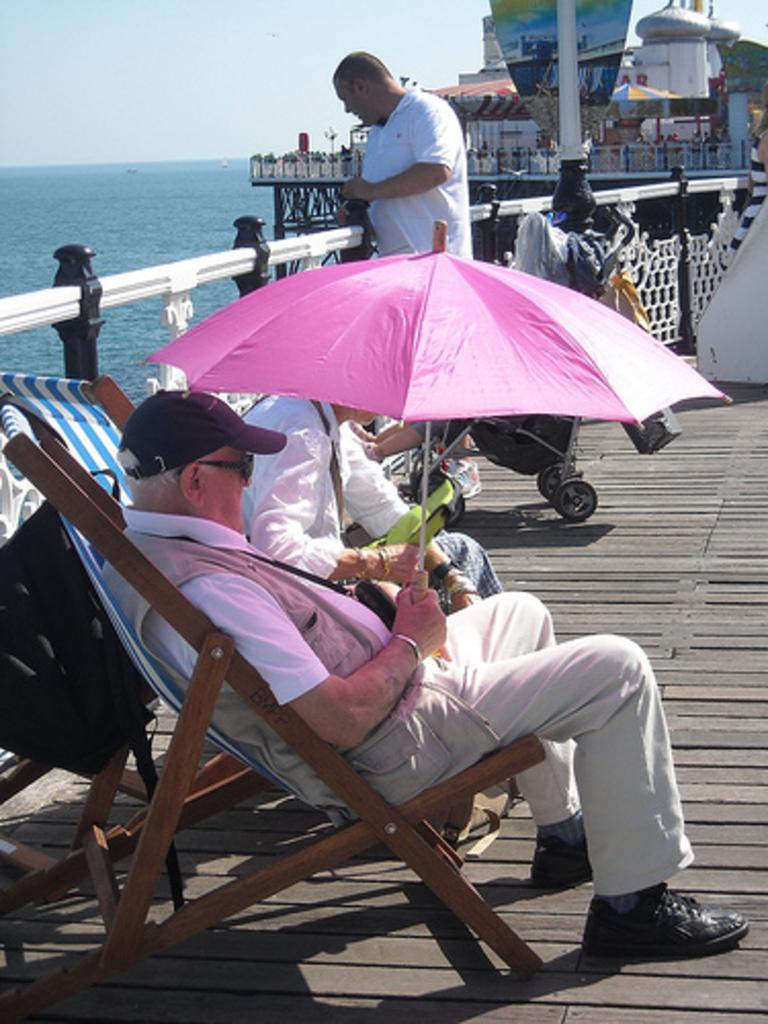Could you give a brief overview of what you see in this image? As we can see in the image there are few people here and there, chair, house, fence, an umbrella, water and sky. 